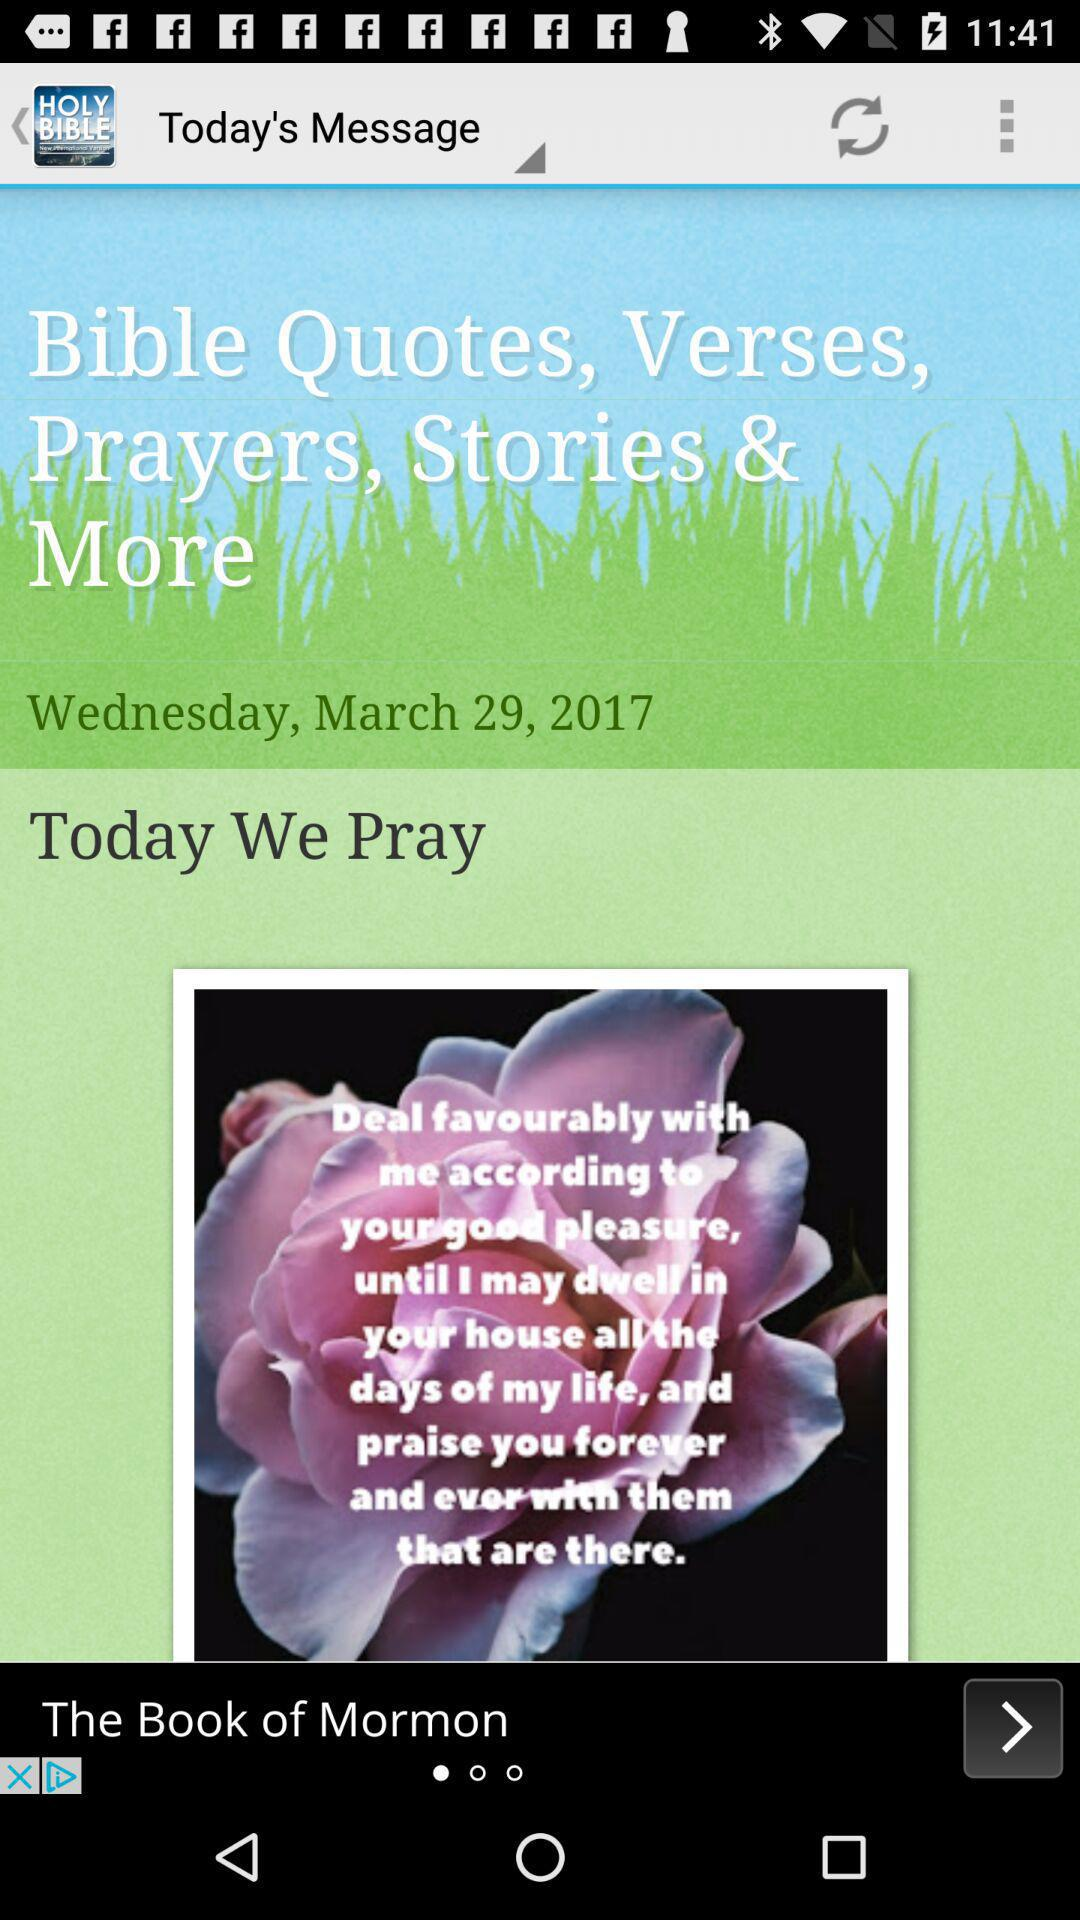What is the date on Wednesday? The date on Wednesday is March 29, 2017. 